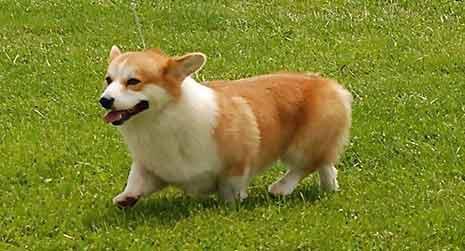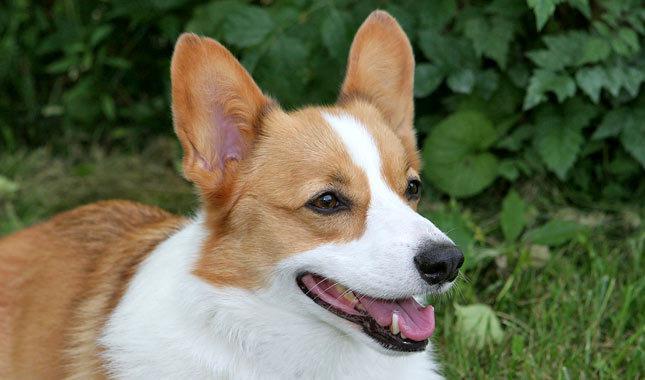The first image is the image on the left, the second image is the image on the right. Assess this claim about the two images: "There is exactly two dogs in the right image.". Correct or not? Answer yes or no. No. The first image is the image on the left, the second image is the image on the right. For the images displayed, is the sentence "An image shows a corgi dog moving across the grass, with one front paw raised." factually correct? Answer yes or no. Yes. The first image is the image on the left, the second image is the image on the right. Considering the images on both sides, is "An image shows a forward-facing dog with its mouth closed." valid? Answer yes or no. No. 